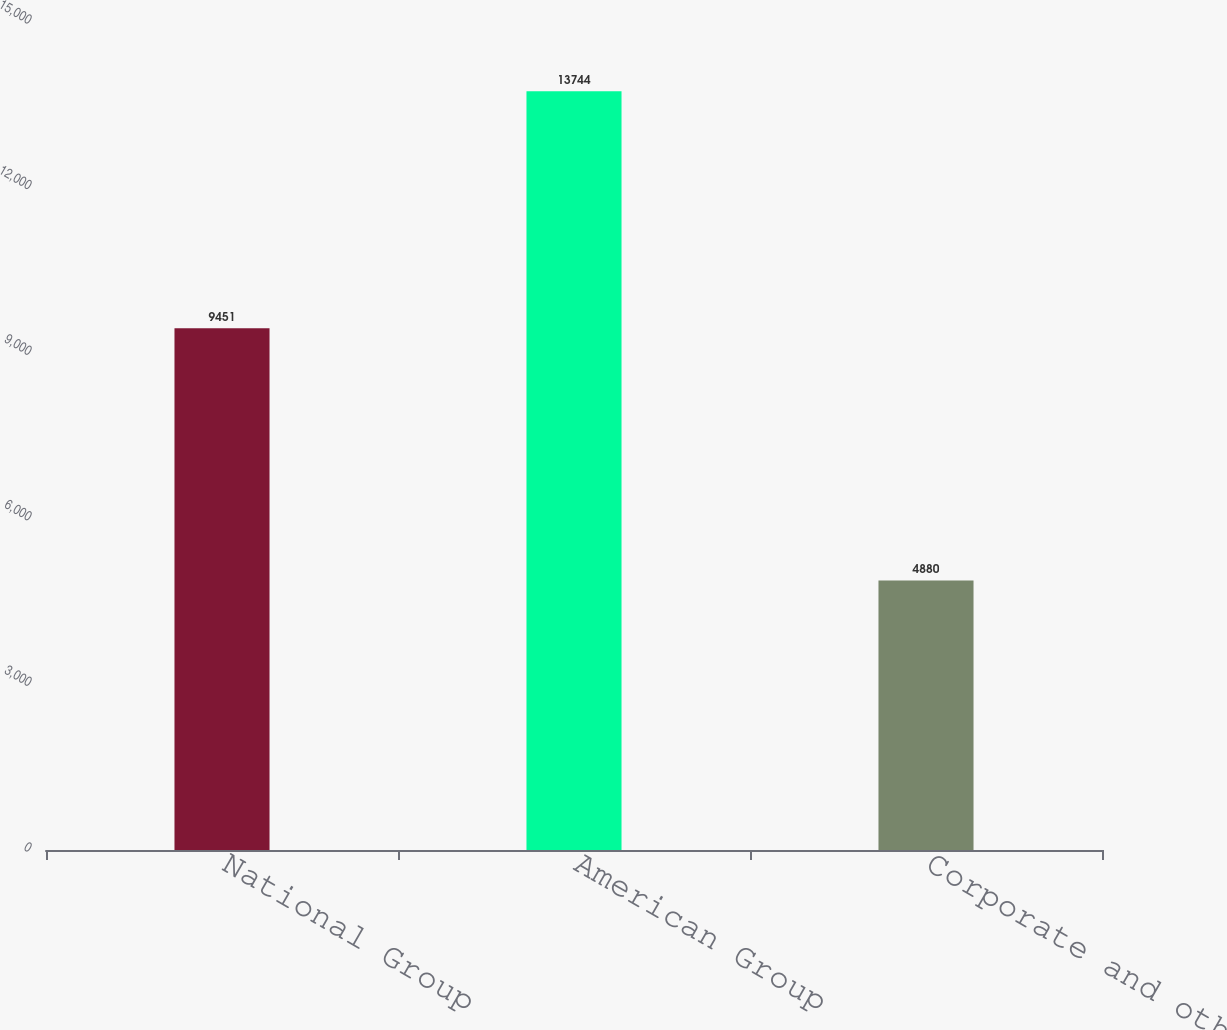Convert chart to OTSL. <chart><loc_0><loc_0><loc_500><loc_500><bar_chart><fcel>National Group<fcel>American Group<fcel>Corporate and other<nl><fcel>9451<fcel>13744<fcel>4880<nl></chart> 